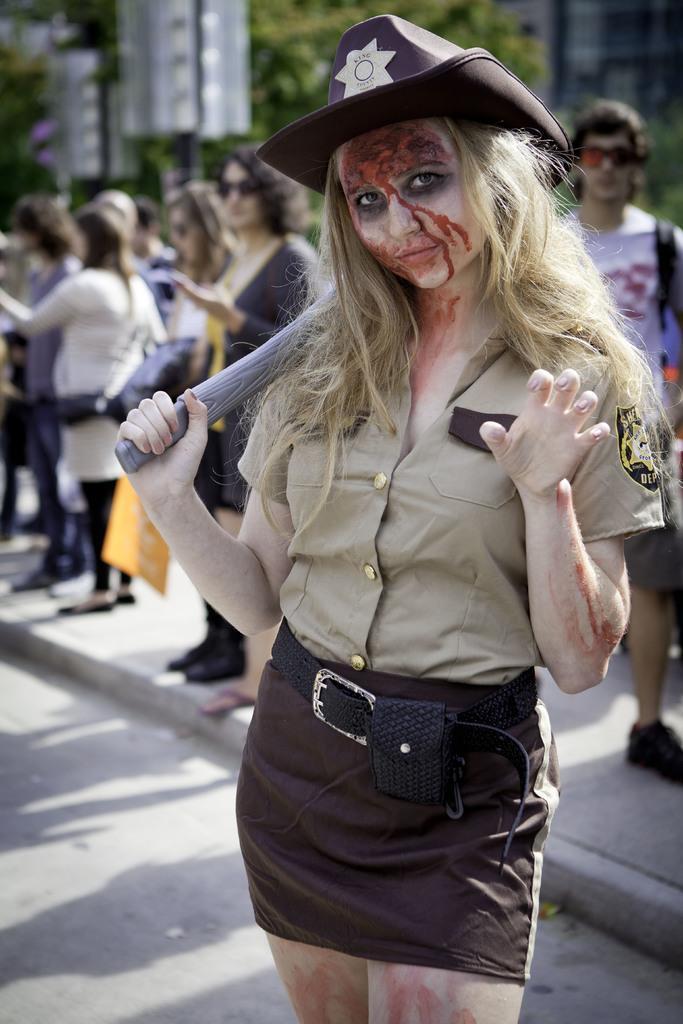Please provide a concise description of this image. In front of the image there is a woman standing and holding some object in her hand, behind the woman on the pavement there are a few other people, behind them there are trees and buildings. 